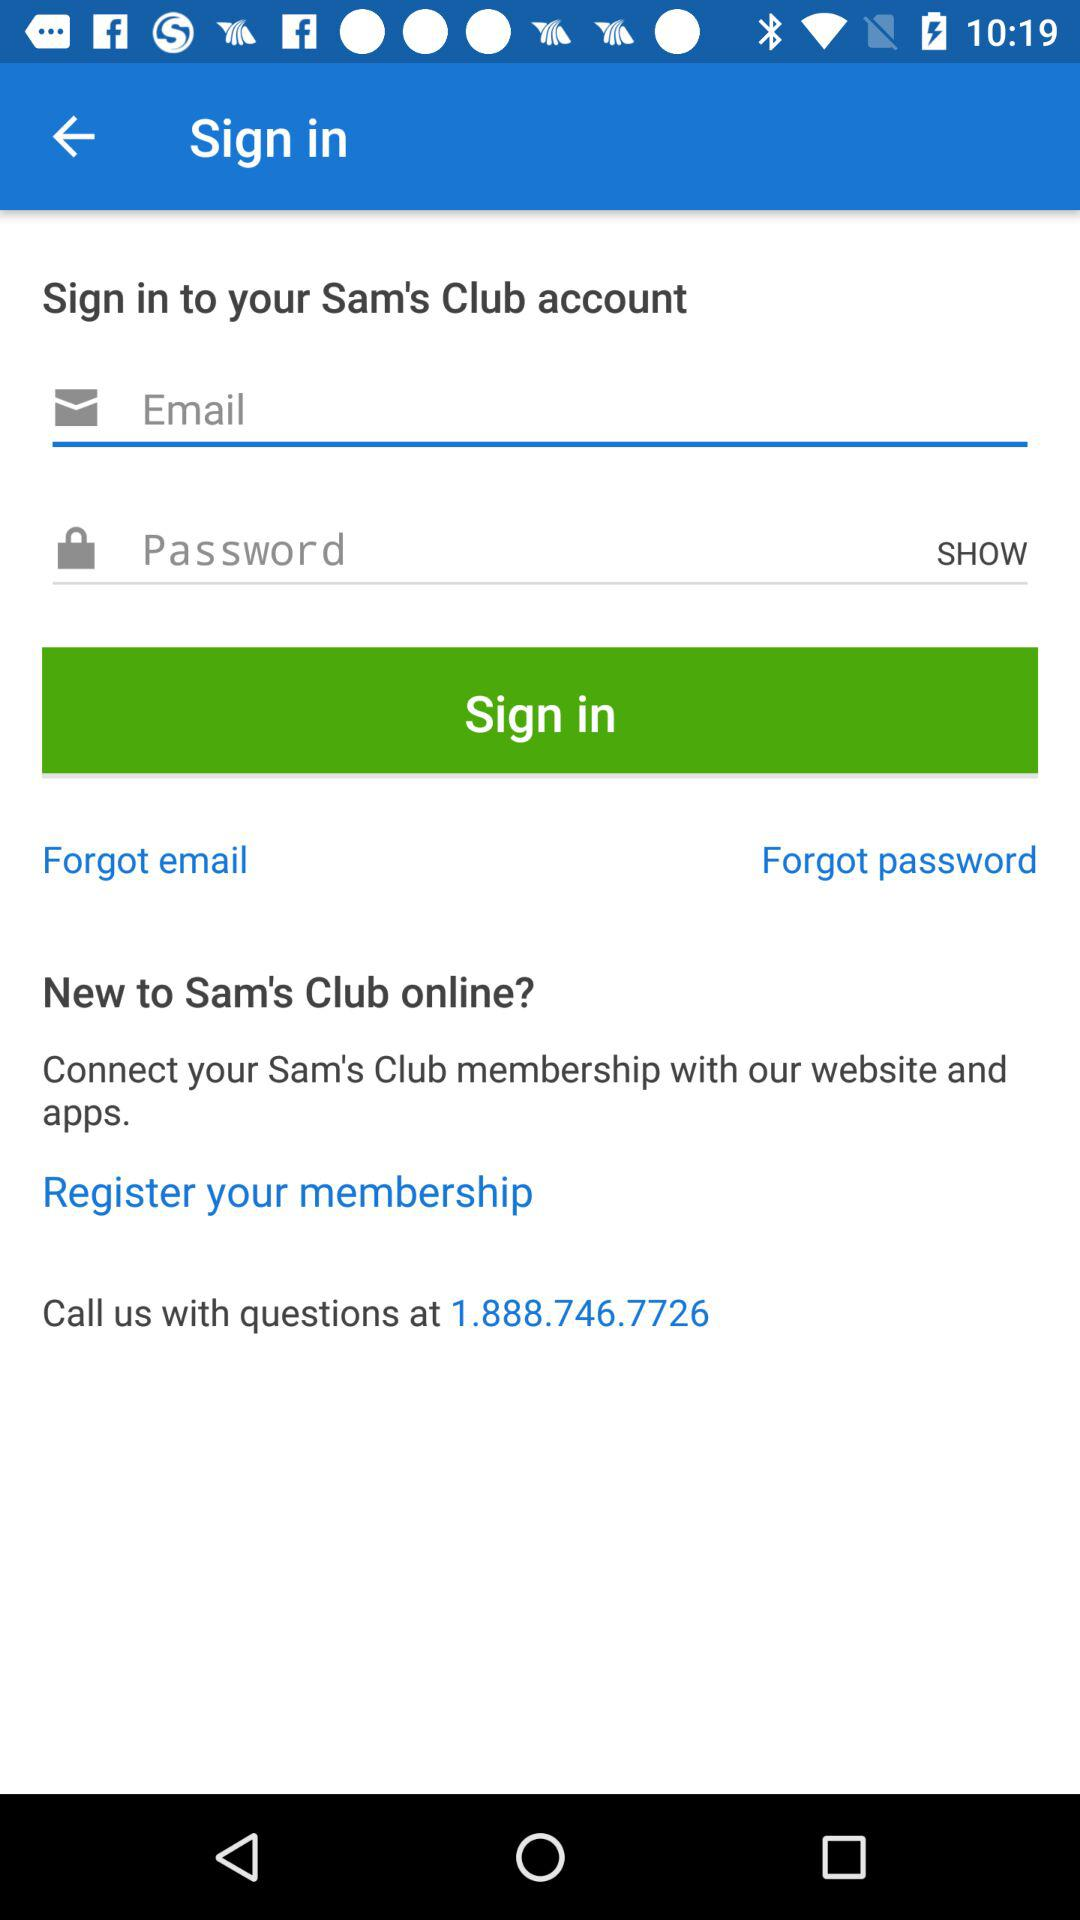What are the requirements to get a sign-in? The requirements are: email and password. 